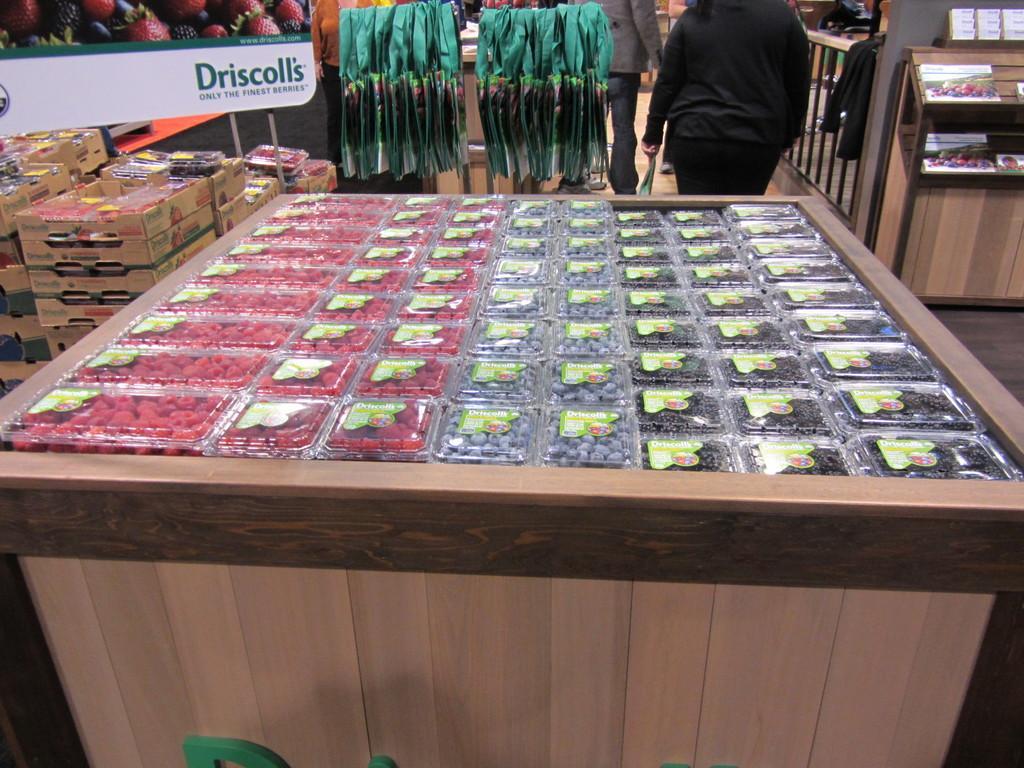In one or two sentences, can you explain what this image depicts? Here we can see food items packed in boxes on the table. In the background there are three persons standing on the floor,cloths,food items packed in boxes,carton boxes. On the right there is a fence,table stand. We can also see a hoarding and this is floor. 